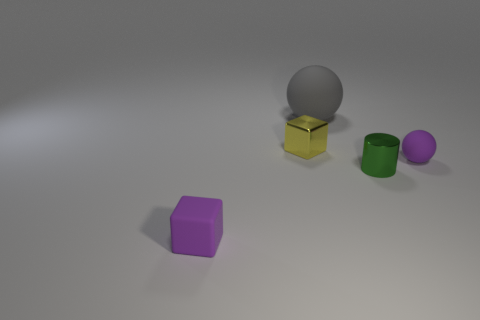Is the number of tiny shiny things right of the small green shiny cylinder greater than the number of gray rubber spheres that are behind the gray matte sphere?
Provide a succinct answer. No. What is the shape of the thing that is the same material as the yellow cube?
Your response must be concise. Cylinder. Is the number of tiny matte things behind the yellow shiny thing greater than the number of large objects?
Provide a short and direct response. No. What number of blocks have the same color as the small rubber ball?
Give a very brief answer. 1. What number of other objects are the same color as the tiny ball?
Your response must be concise. 1. Is the number of shiny cylinders greater than the number of green matte blocks?
Ensure brevity in your answer.  Yes. What is the material of the cylinder?
Give a very brief answer. Metal. Do the purple ball right of the yellow object and the cylinder have the same size?
Your answer should be very brief. Yes. There is a purple object that is on the right side of the tiny yellow metallic thing; what is its size?
Ensure brevity in your answer.  Small. Are there any other things that have the same material as the tiny green object?
Your answer should be very brief. Yes. 